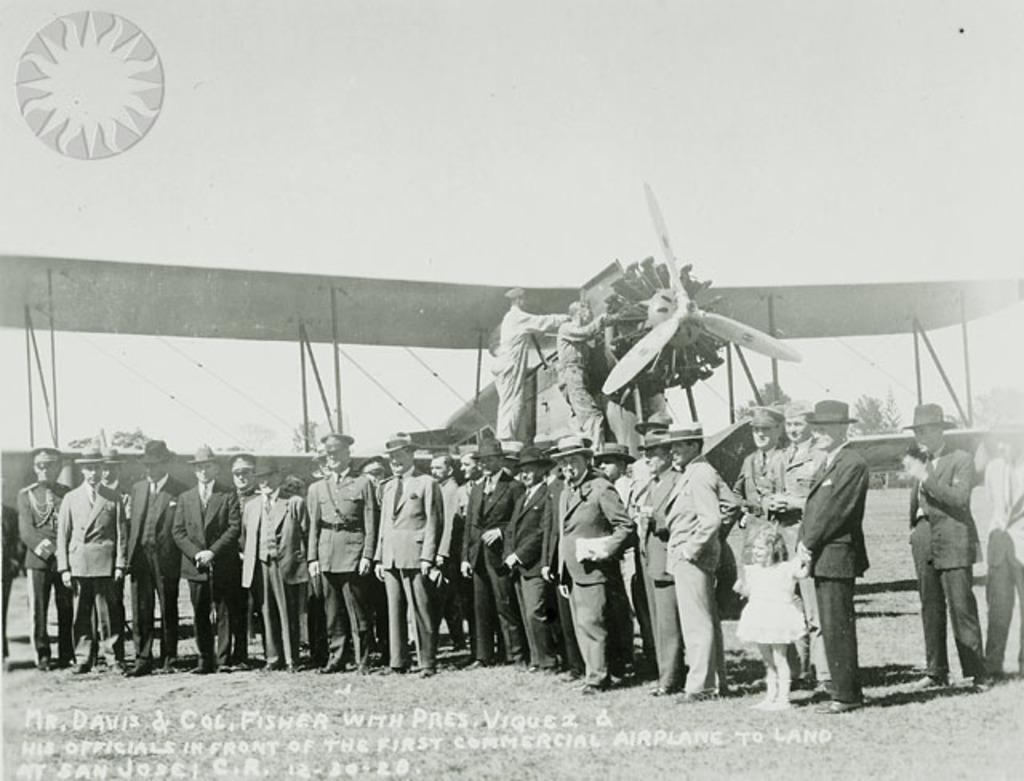<image>
Present a compact description of the photo's key features. the name Fisher is at the bottom of the men 